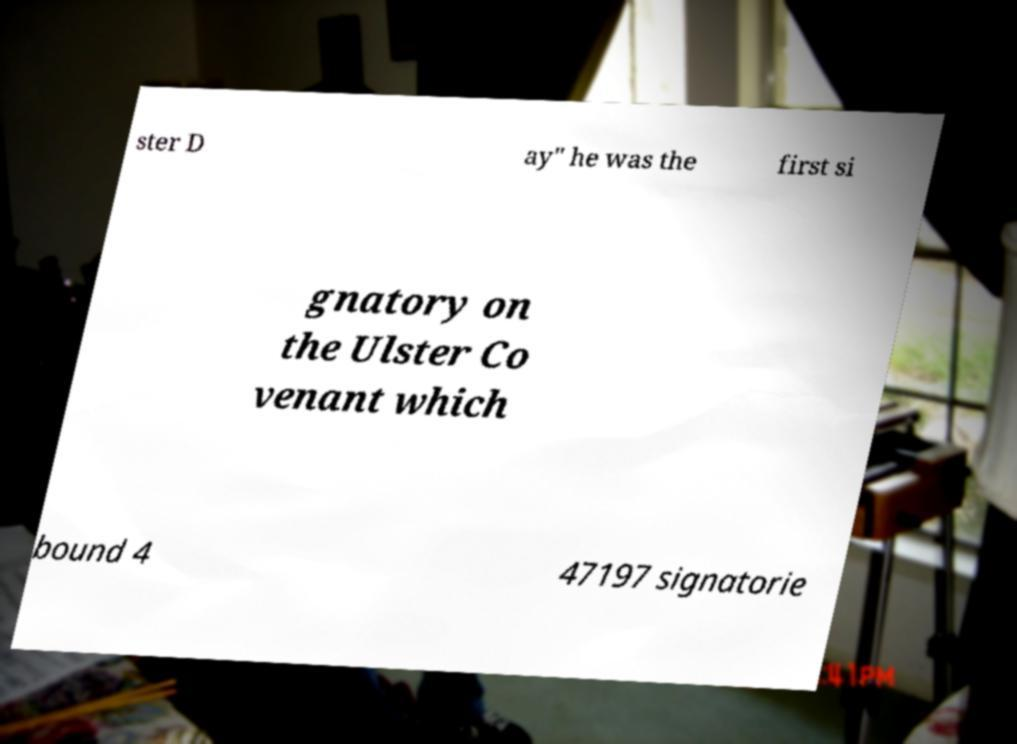What messages or text are displayed in this image? I need them in a readable, typed format. ster D ay" he was the first si gnatory on the Ulster Co venant which bound 4 47197 signatorie 